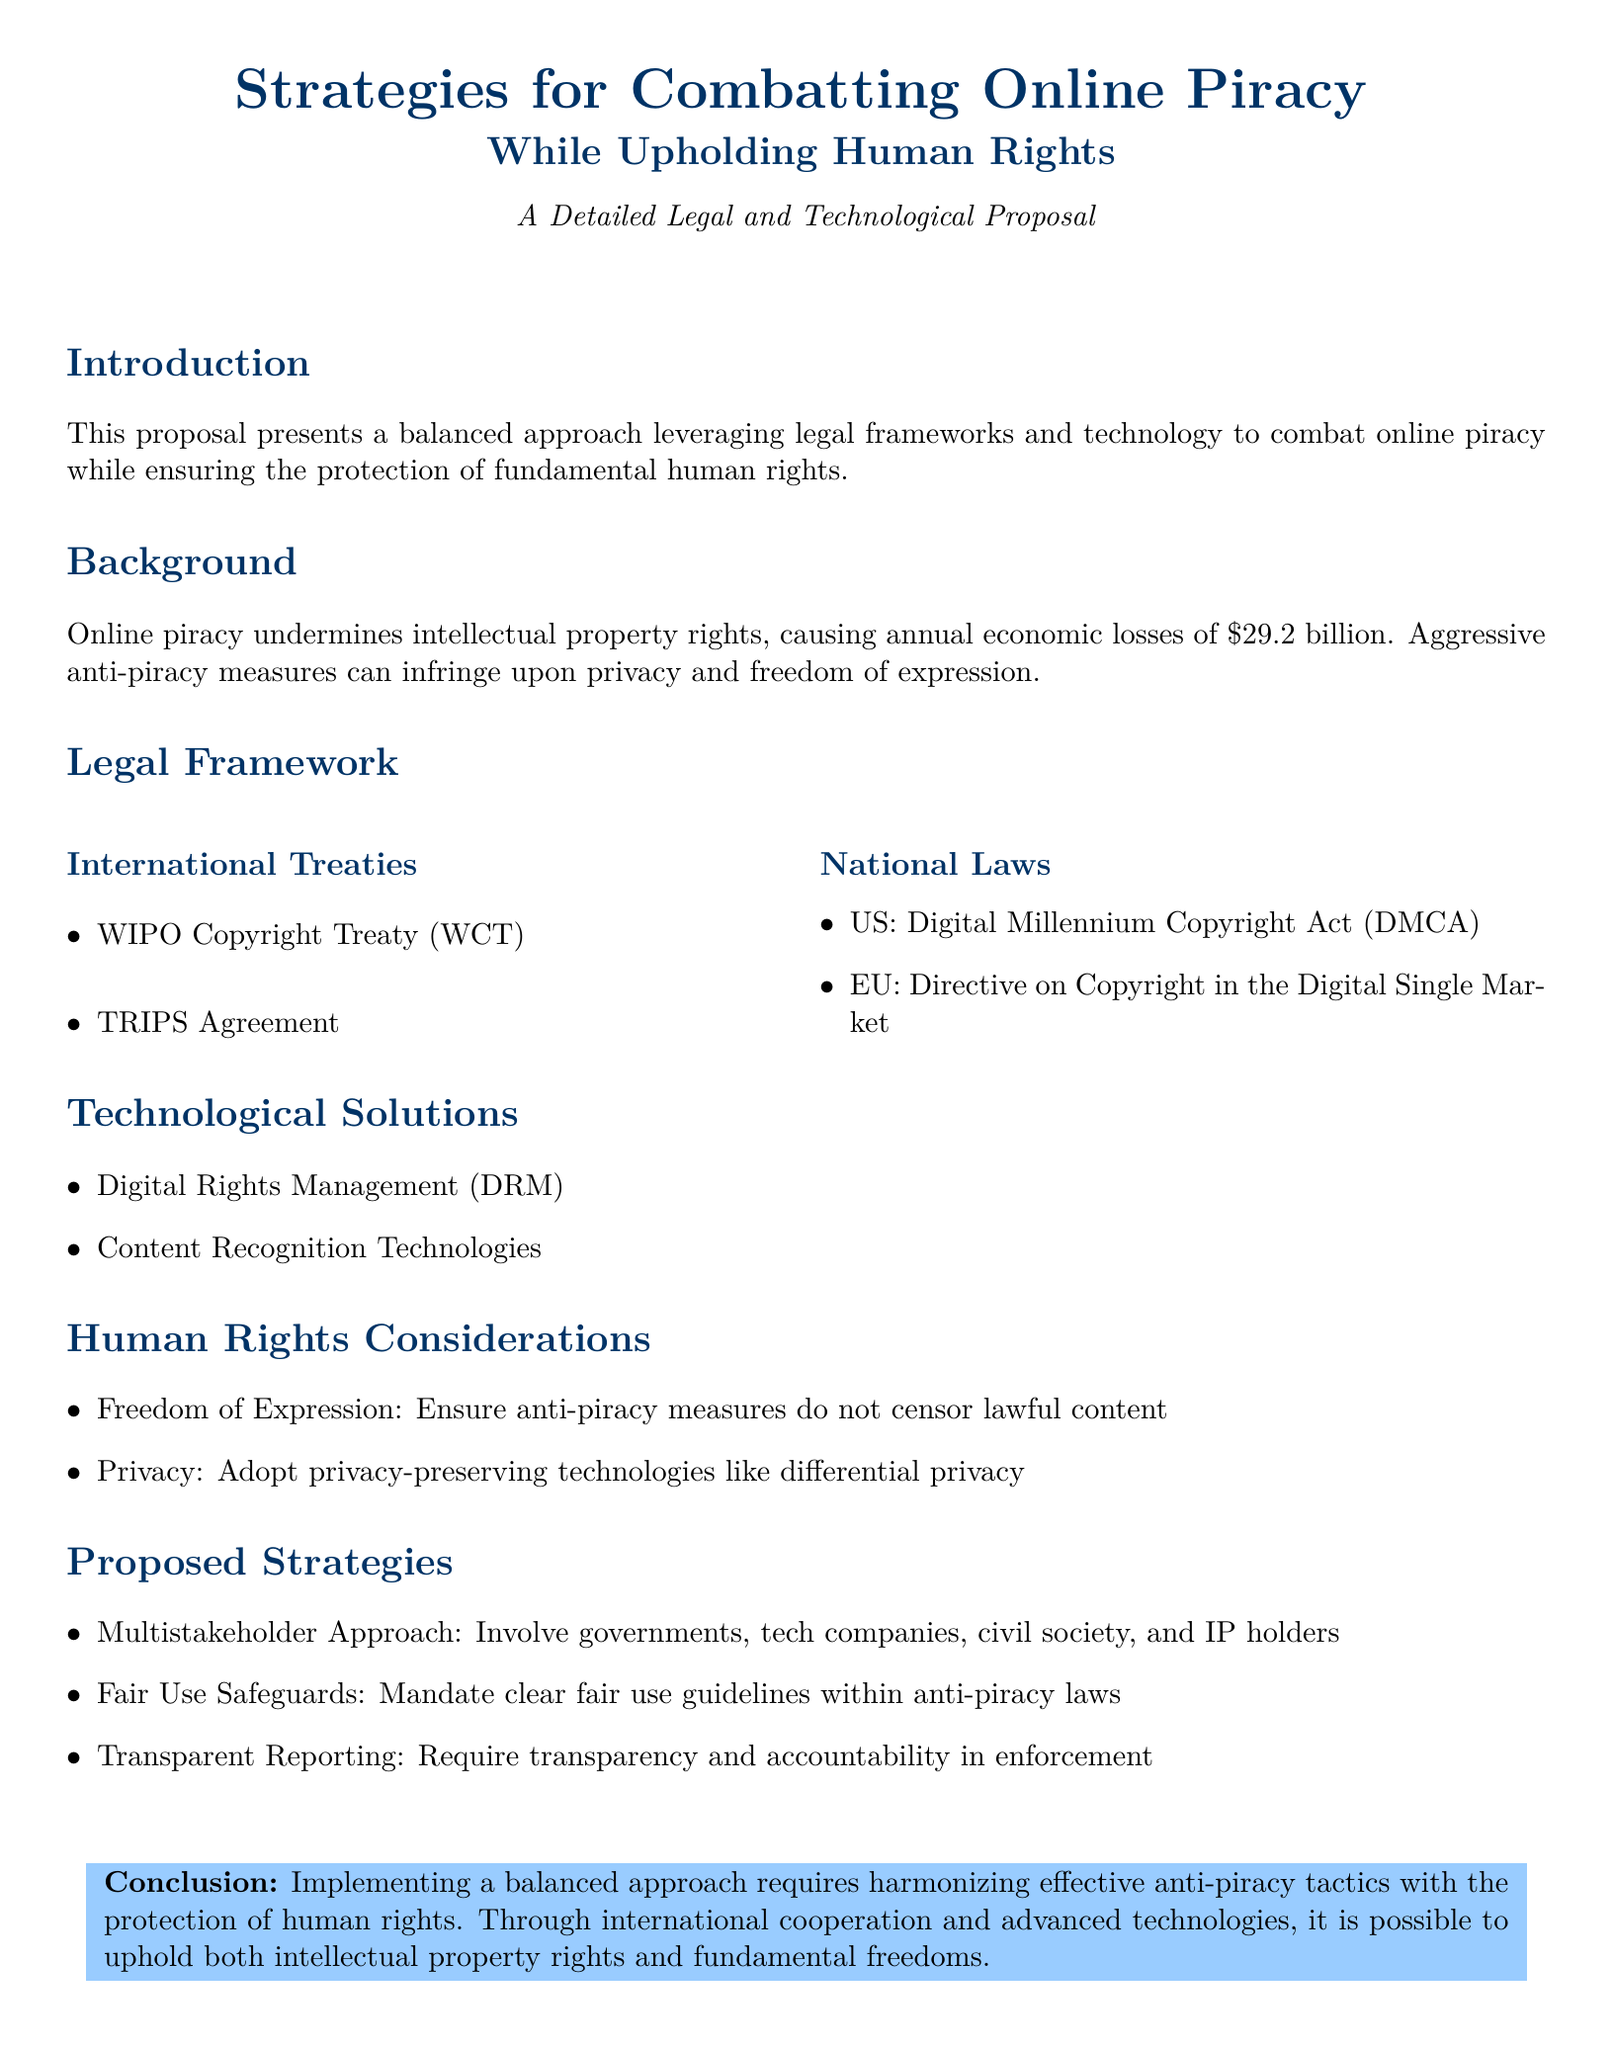What is the annual economic loss due to online piracy? The document states that online piracy causes annual economic losses of $29.2 billion.
Answer: $29.2 billion Which international treaty is mentioned for copyright protection? The proposal lists the WIPO Copyright Treaty (WCT) as one of the international treaties.
Answer: WIPO Copyright Treaty (WCT) What technological solution is included in the proposal? The document mentions Digital Rights Management (DRM) as a technological solution.
Answer: Digital Rights Management (DRM) Who should be involved in the multistakeholder approach? The proposal suggests involving governments, tech companies, civil society, and IP holders in the multistakeholder approach.
Answer: Governments, tech companies, civil society, IP holders What is the key human rights consideration mentioned in the document? The proposal highlights freedom of expression as a key human rights consideration.
Answer: Freedom of Expression 